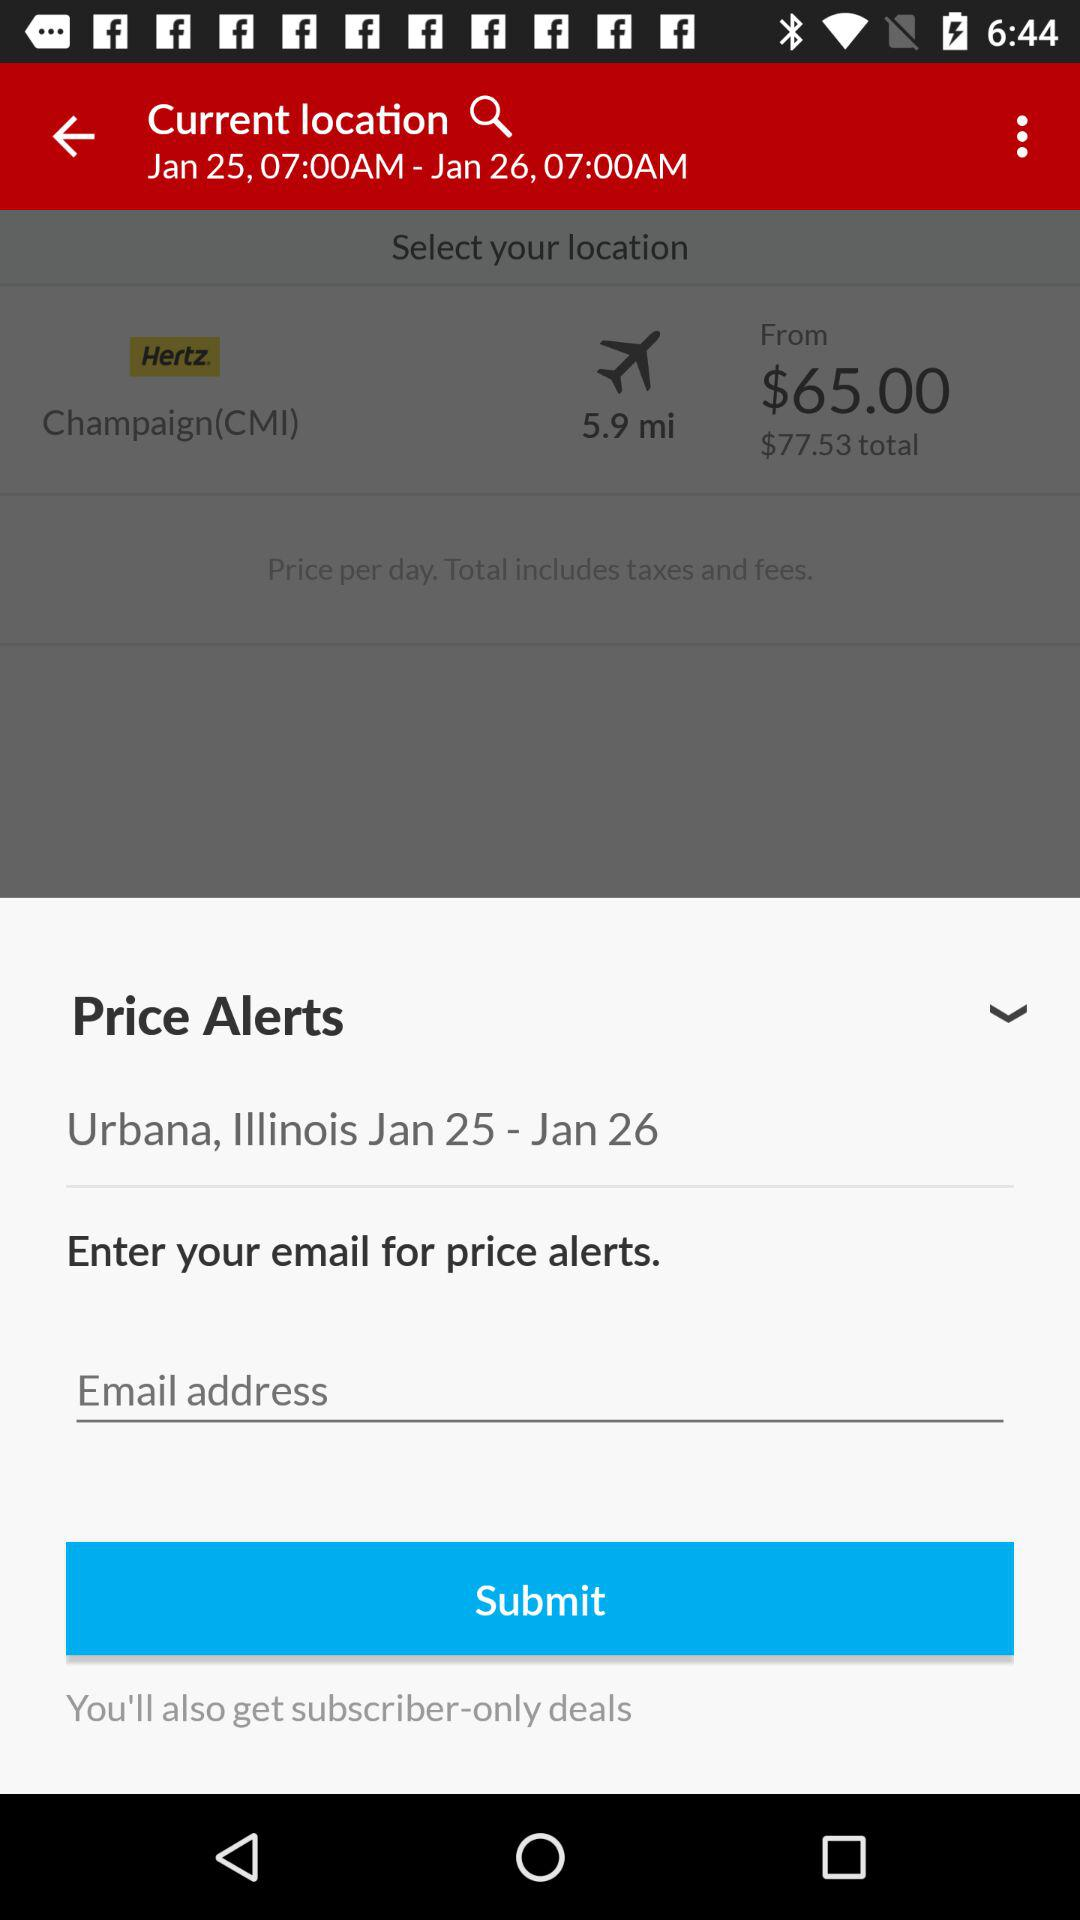How much is the total price including taxes and fees?
Answer the question using a single word or phrase. $77.53 